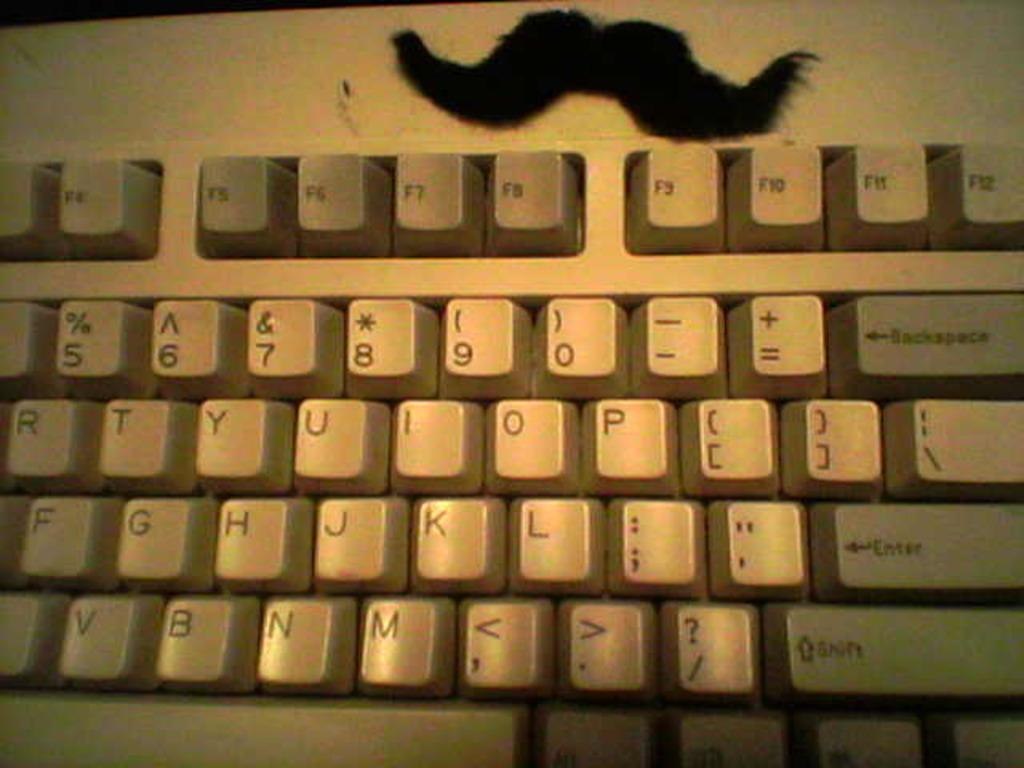<image>
Write a terse but informative summary of the picture. a beige keyboard with keys such as Enter and Shift 